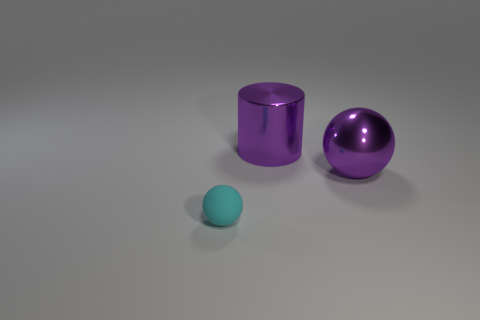Is there any other thing that has the same material as the cyan object?
Offer a very short reply. No. The other shiny thing that is the same shape as the small cyan object is what color?
Ensure brevity in your answer.  Purple. The object that is behind the cyan rubber thing and left of the large purple metallic sphere is made of what material?
Give a very brief answer. Metal. Is the purple thing that is behind the big metal ball made of the same material as the sphere that is behind the matte ball?
Make the answer very short. Yes. The cyan matte object is what size?
Give a very brief answer. Small. There is another thing that is the same shape as the cyan matte thing; what size is it?
Offer a very short reply. Large. There is a small matte ball; how many big purple objects are in front of it?
Provide a short and direct response. 0. What is the color of the shiny cylinder on the left side of the sphere to the right of the matte thing?
Offer a very short reply. Purple. Are there the same number of large purple objects that are on the left side of the big purple metal cylinder and big purple shiny cylinders in front of the big purple metallic sphere?
Offer a very short reply. Yes. What number of cubes are purple metal things or large green metallic objects?
Offer a very short reply. 0. 